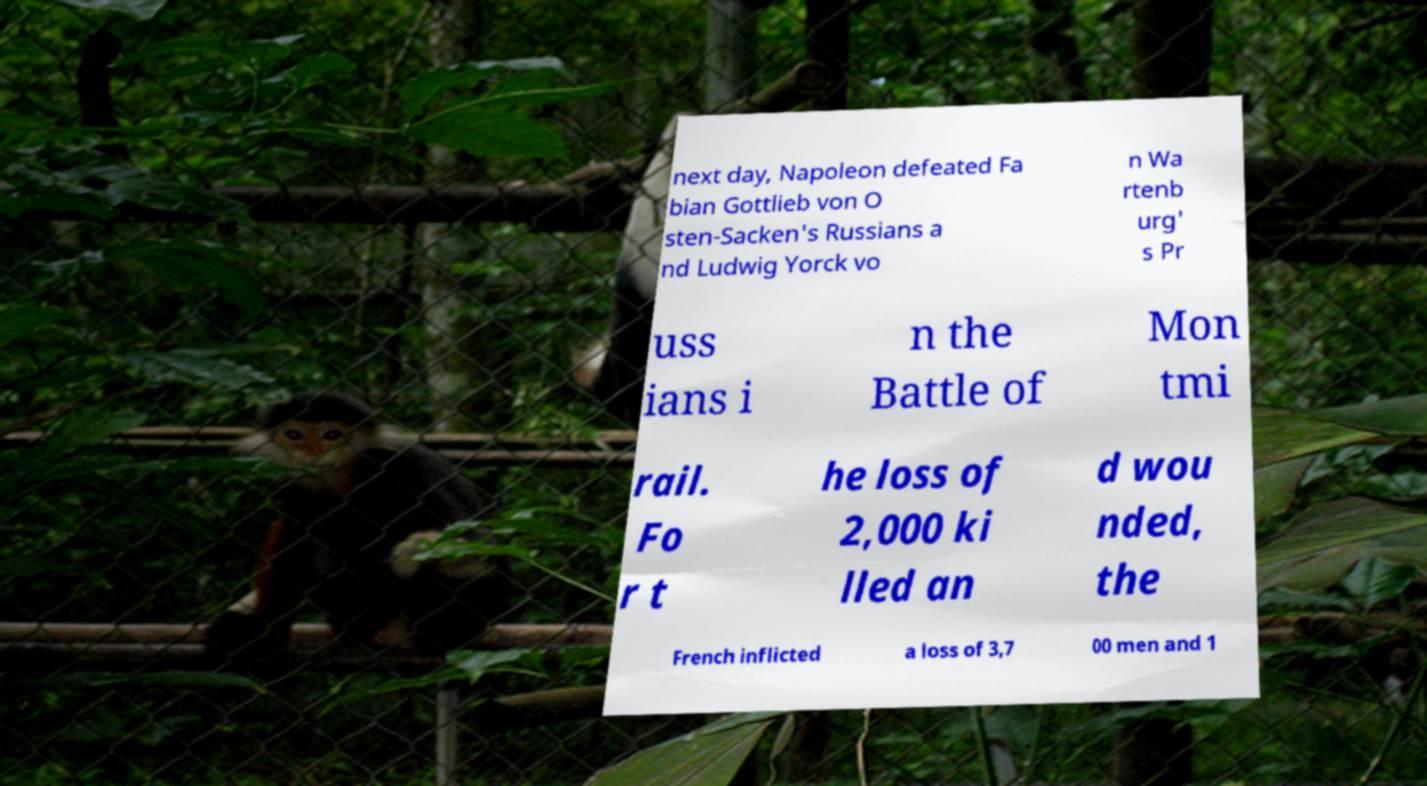Please identify and transcribe the text found in this image. next day, Napoleon defeated Fa bian Gottlieb von O sten-Sacken's Russians a nd Ludwig Yorck vo n Wa rtenb urg' s Pr uss ians i n the Battle of Mon tmi rail. Fo r t he loss of 2,000 ki lled an d wou nded, the French inflicted a loss of 3,7 00 men and 1 